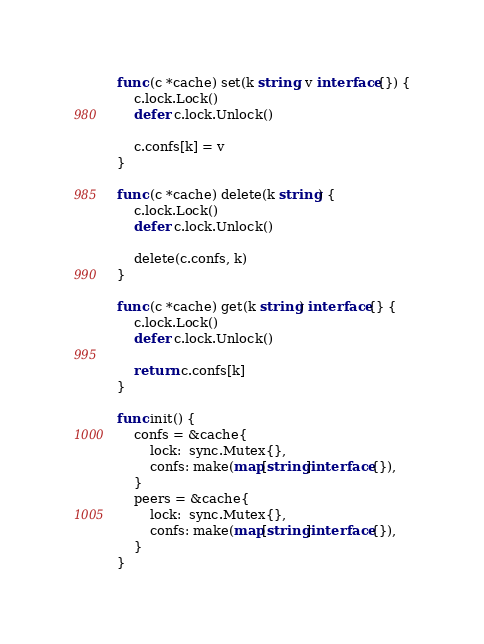<code> <loc_0><loc_0><loc_500><loc_500><_Go_>
func (c *cache) set(k string, v interface{}) {
	c.lock.Lock()
	defer c.lock.Unlock()

	c.confs[k] = v
}

func (c *cache) delete(k string) {
	c.lock.Lock()
	defer c.lock.Unlock()

	delete(c.confs, k)
}

func (c *cache) get(k string) interface{} {
	c.lock.Lock()
	defer c.lock.Unlock()

	return c.confs[k]
}

func init() {
	confs = &cache{
		lock:  sync.Mutex{},
		confs: make(map[string]interface{}),
	}
	peers = &cache{
		lock:  sync.Mutex{},
		confs: make(map[string]interface{}),
	}
}
</code> 